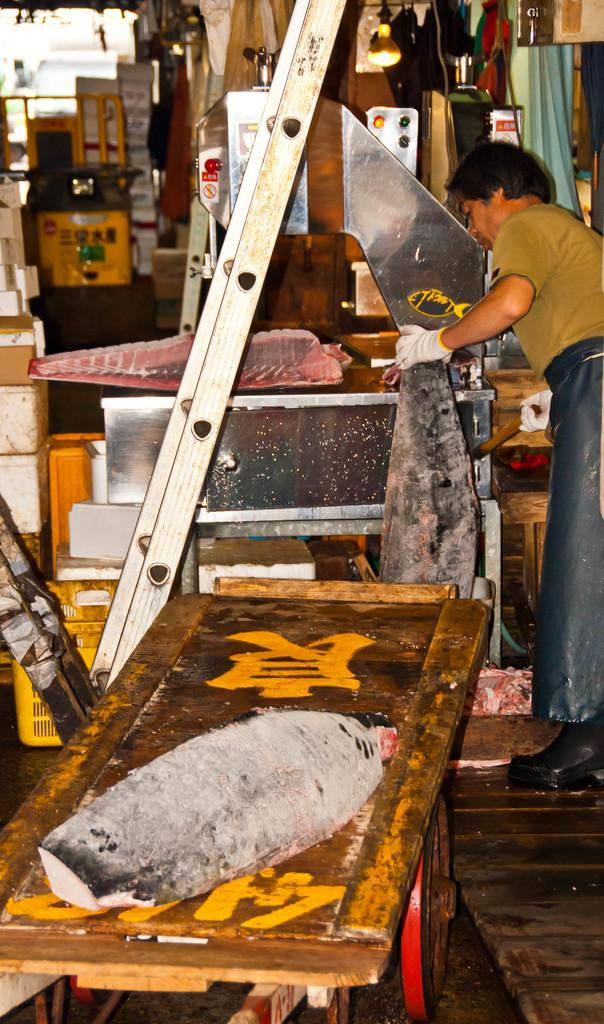What is the person in the image doing? The person is standing and holding something in the image. What can be seen near the person? There is a trolley in the image. What is on the trolley? There is an object on the trolley. What can be seen in the background of the image? There are objects visible in the background, including a yellow basket and a ladder. How many bears are visible on the ladder in the background? There are no bears visible in the image, let alone on the ladder in the background. 